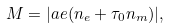<formula> <loc_0><loc_0><loc_500><loc_500>M = | a e ( n _ { e } + \tau _ { 0 } n _ { m } ) | ,</formula> 